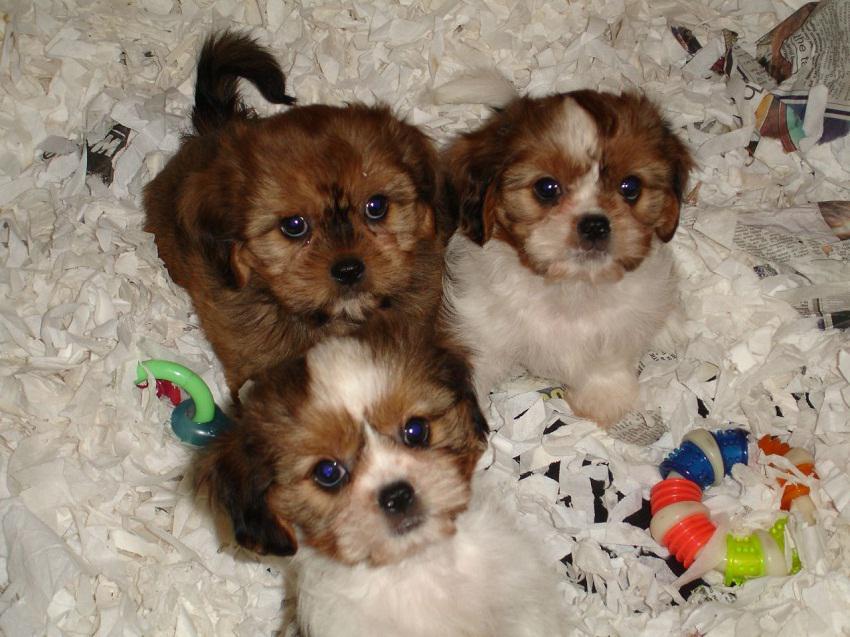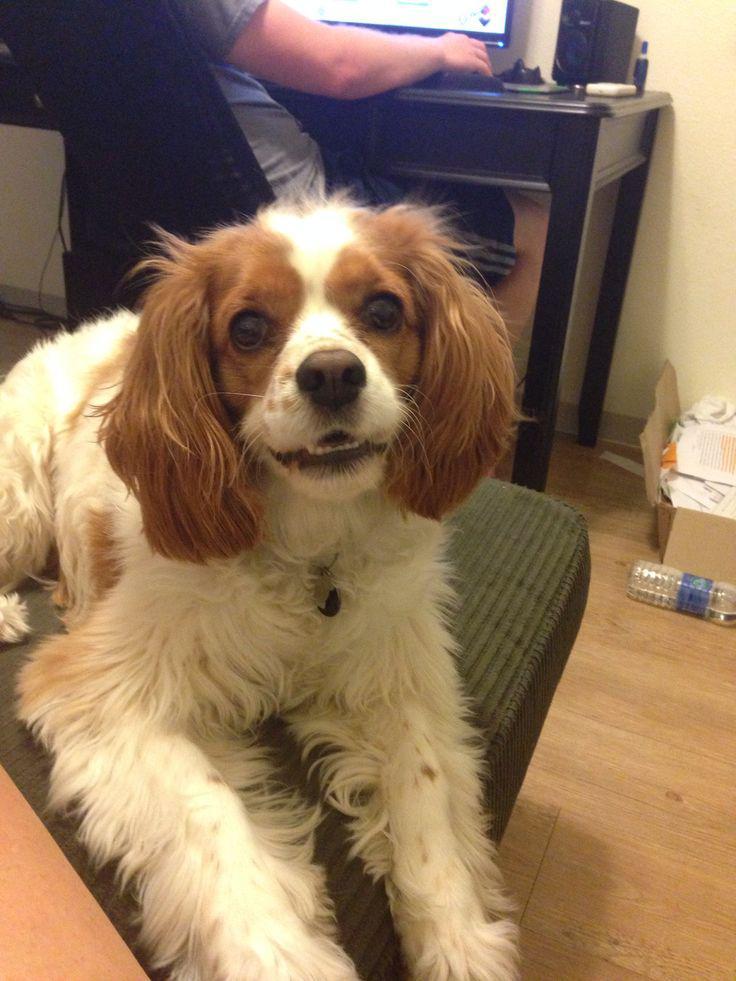The first image is the image on the left, the second image is the image on the right. Evaluate the accuracy of this statement regarding the images: "At least one of the dogs is sitting outside.". Is it true? Answer yes or no. No. The first image is the image on the left, the second image is the image on the right. Examine the images to the left and right. Is the description "An image contains at least two dogs." accurate? Answer yes or no. Yes. 